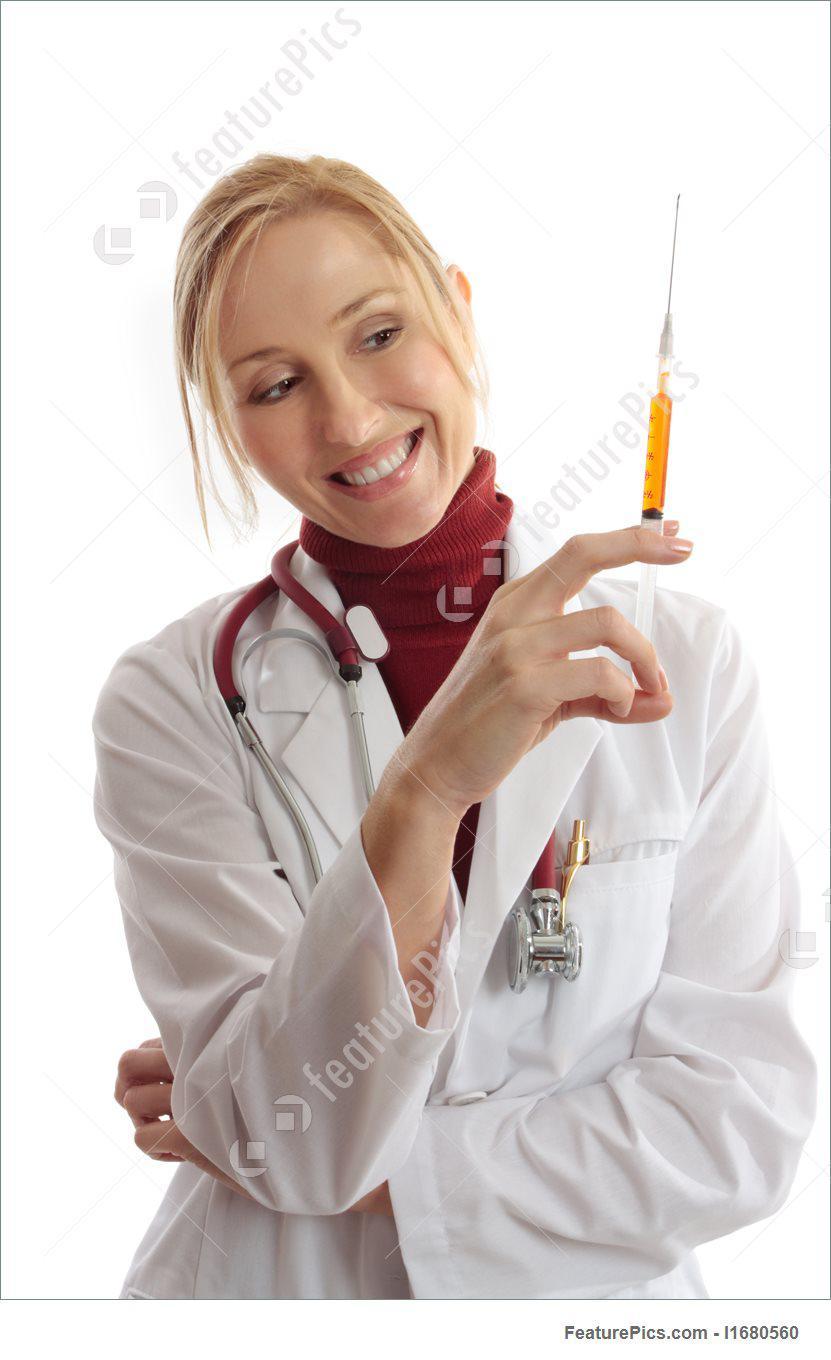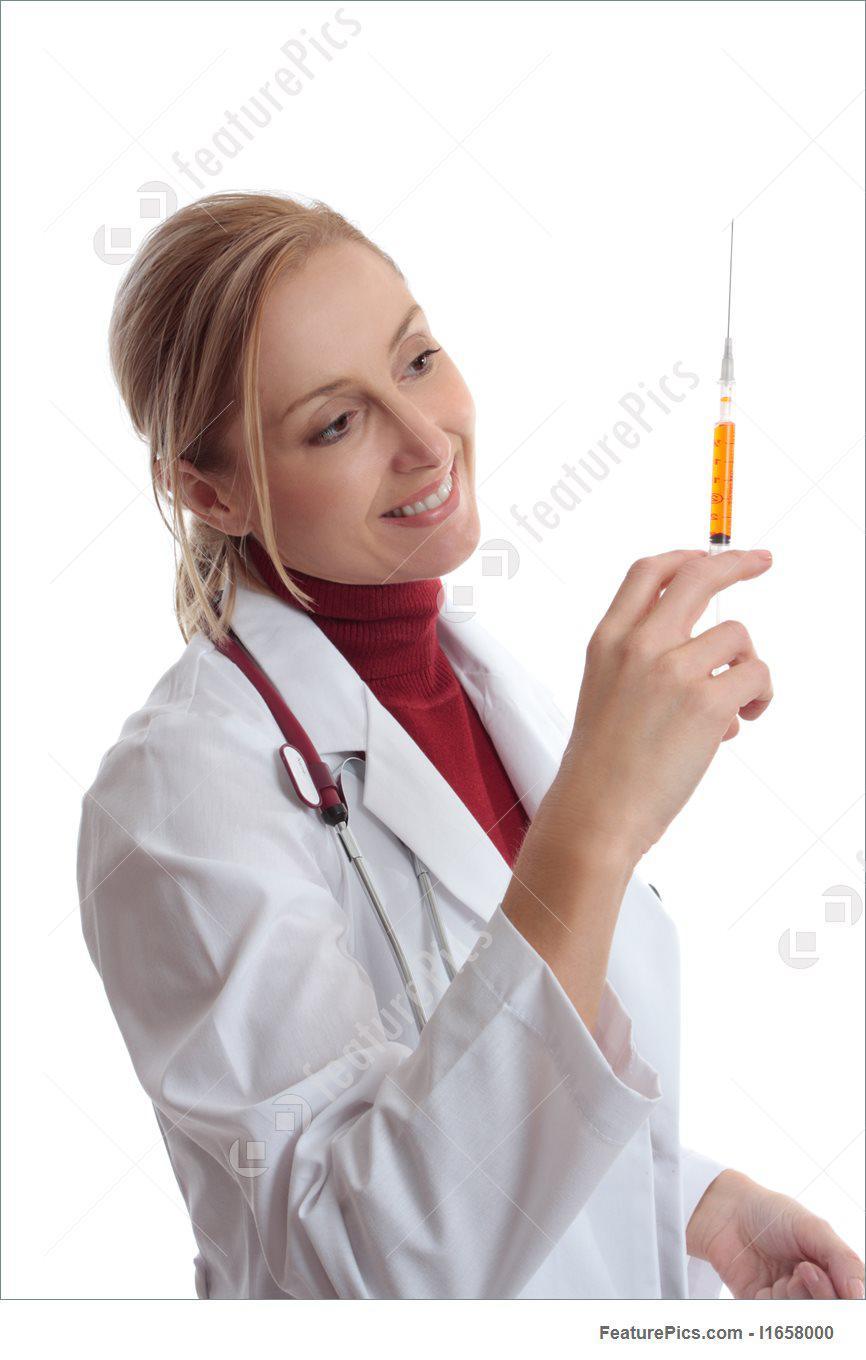The first image is the image on the left, the second image is the image on the right. Considering the images on both sides, is "There are two women holding a needle with colored liquid in it." valid? Answer yes or no. Yes. The first image is the image on the left, the second image is the image on the right. Given the left and right images, does the statement "The liquid in at least one of the syringes is orange." hold true? Answer yes or no. Yes. 